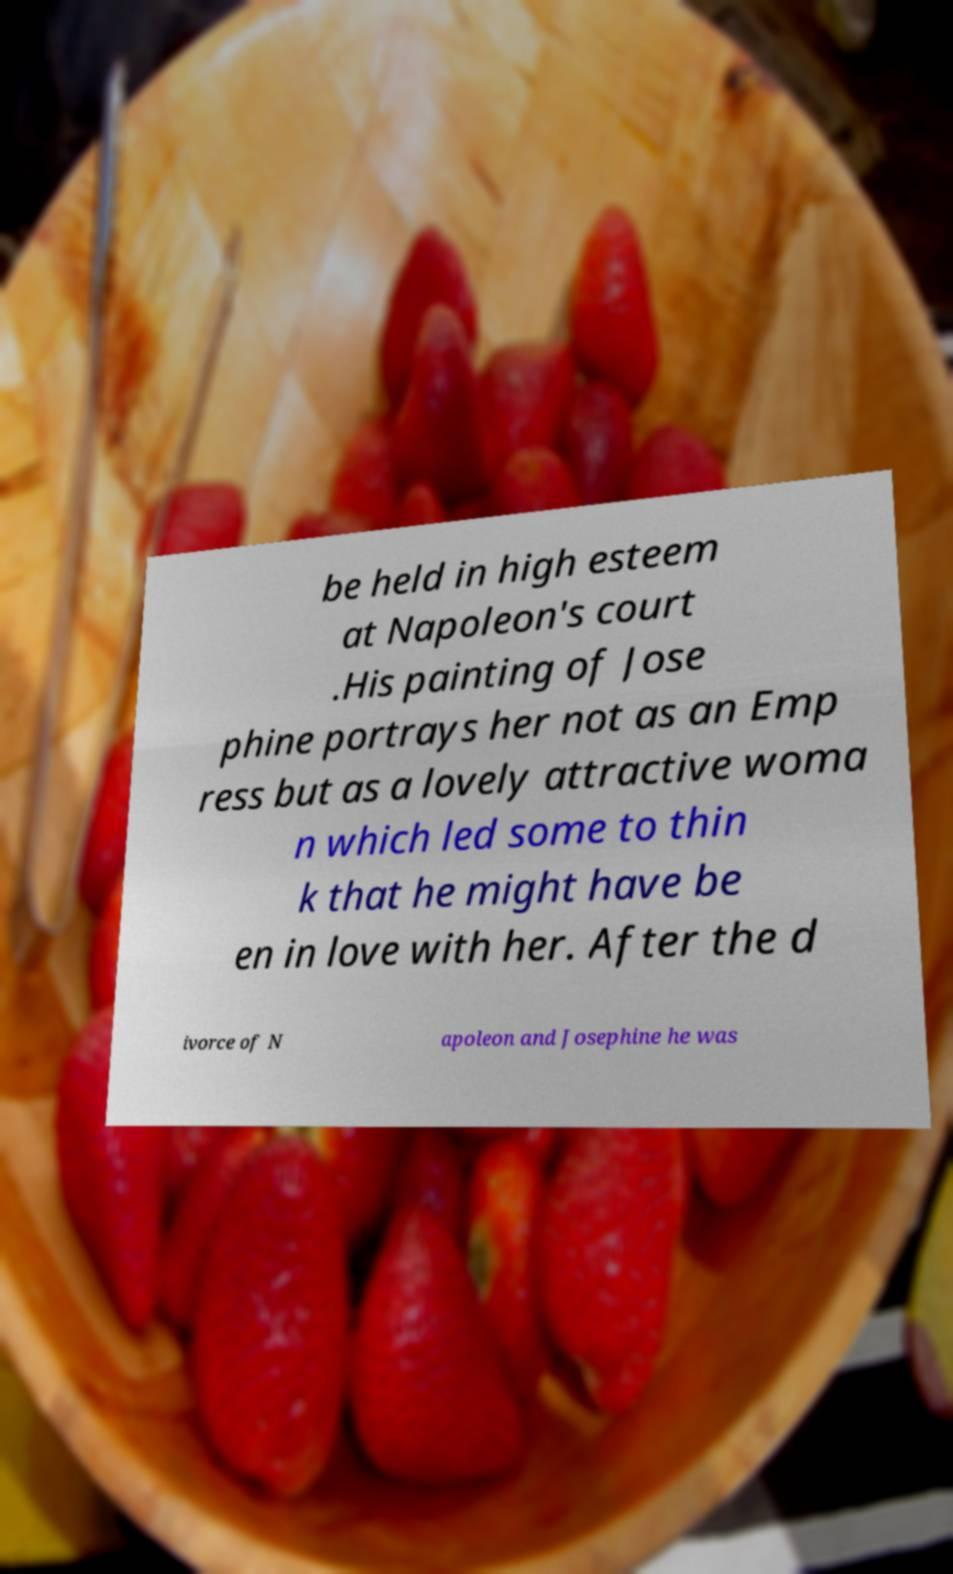Please identify and transcribe the text found in this image. be held in high esteem at Napoleon's court .His painting of Jose phine portrays her not as an Emp ress but as a lovely attractive woma n which led some to thin k that he might have be en in love with her. After the d ivorce of N apoleon and Josephine he was 